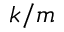Convert formula to latex. <formula><loc_0><loc_0><loc_500><loc_500>k / m</formula> 